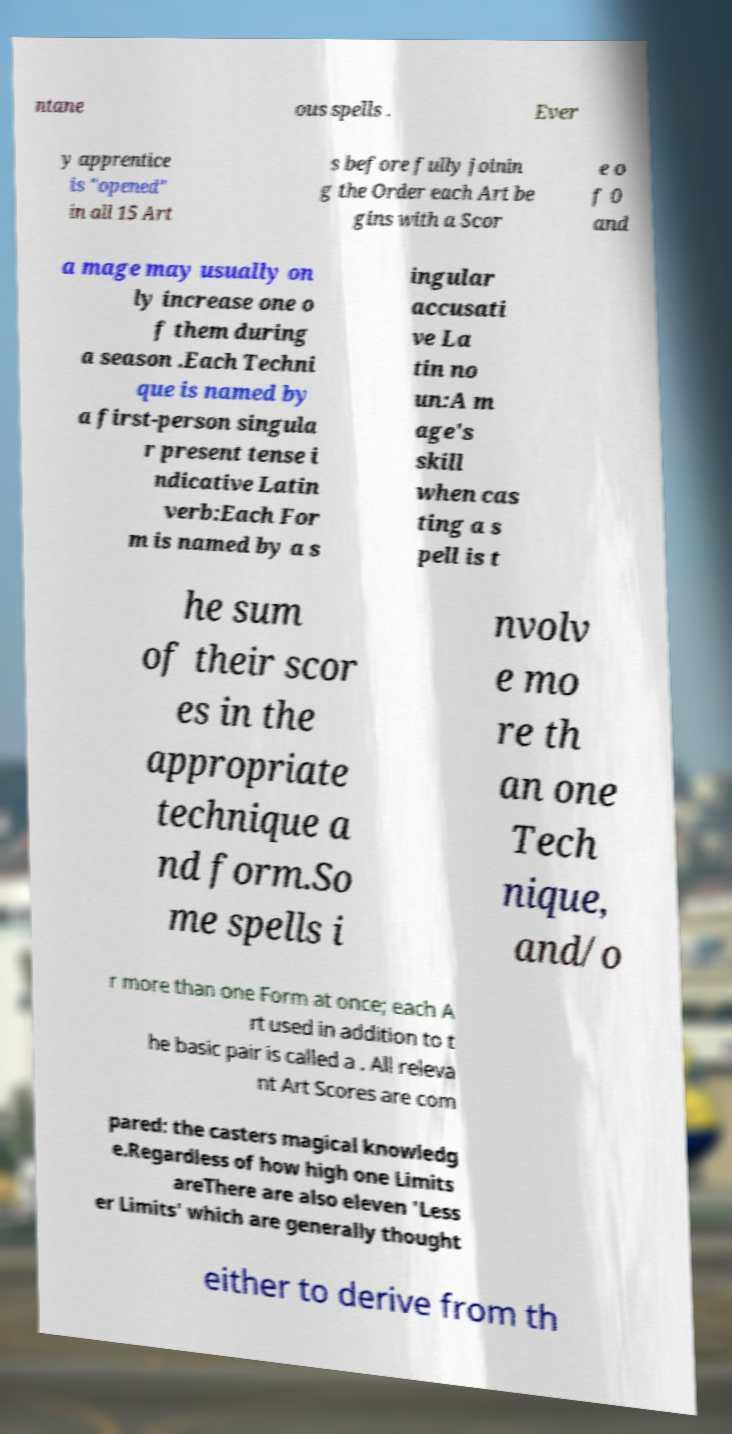Could you assist in decoding the text presented in this image and type it out clearly? ntane ous spells . Ever y apprentice is "opened" in all 15 Art s before fully joinin g the Order each Art be gins with a Scor e o f 0 and a mage may usually on ly increase one o f them during a season .Each Techni que is named by a first-person singula r present tense i ndicative Latin verb:Each For m is named by a s ingular accusati ve La tin no un:A m age's skill when cas ting a s pell is t he sum of their scor es in the appropriate technique a nd form.So me spells i nvolv e mo re th an one Tech nique, and/o r more than one Form at once; each A rt used in addition to t he basic pair is called a . All releva nt Art Scores are com pared: the casters magical knowledg e.Regardless of how high one Limits areThere are also eleven 'Less er Limits' which are generally thought either to derive from th 